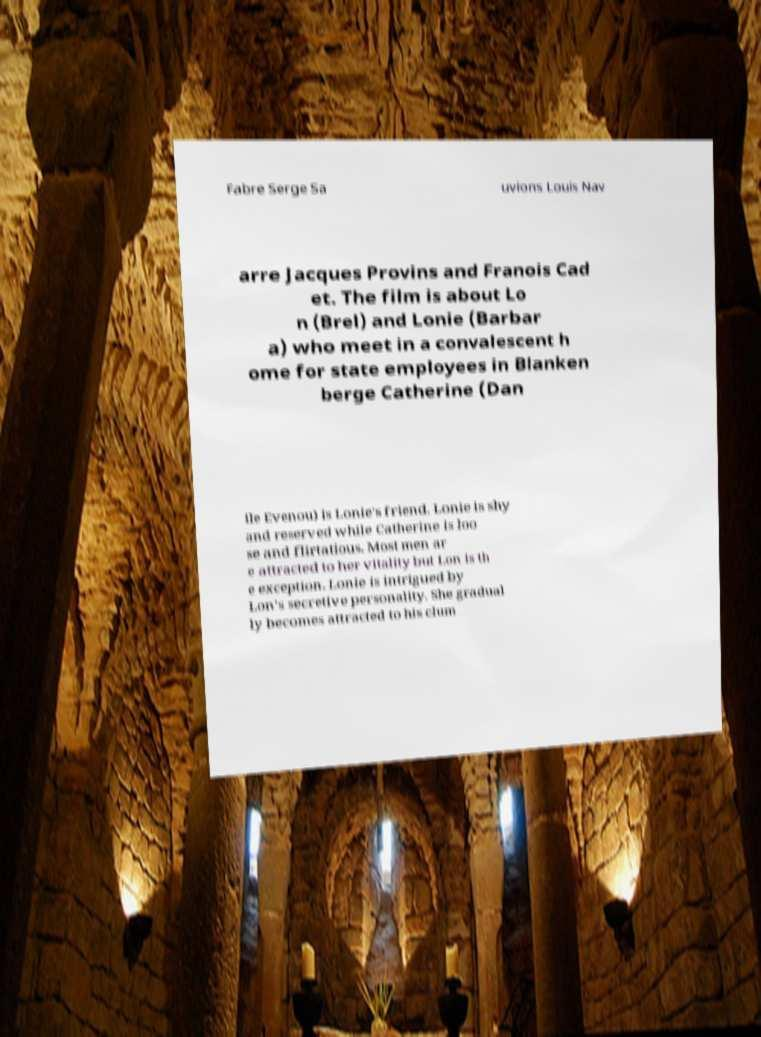Please read and relay the text visible in this image. What does it say? Fabre Serge Sa uvions Louis Nav arre Jacques Provins and Franois Cad et. The film is about Lo n (Brel) and Lonie (Barbar a) who meet in a convalescent h ome for state employees in Blanken berge Catherine (Dan ile Evenou) is Lonie's friend. Lonie is shy and reserved while Catherine is loo se and flirtatious. Most men ar e attracted to her vitality but Lon is th e exception. Lonie is intrigued by Lon's secretive personality. She gradual ly becomes attracted to his clum 